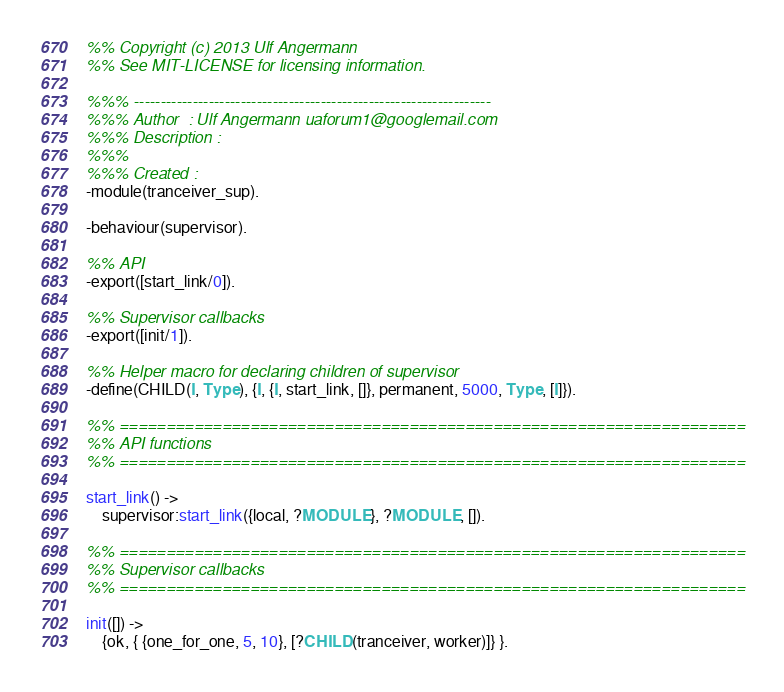<code> <loc_0><loc_0><loc_500><loc_500><_Erlang_>%% Copyright (c) 2013 Ulf Angermann
%% See MIT-LICENSE for licensing information.

%%% -------------------------------------------------------------------
%%% Author  : Ulf Angermann uaforum1@googlemail.com
%%% Description :
%%%
%%% Created : 
-module(tranceiver_sup).

-behaviour(supervisor).

%% API
-export([start_link/0]).

%% Supervisor callbacks
-export([init/1]).

%% Helper macro for declaring children of supervisor
-define(CHILD(I, Type), {I, {I, start_link, []}, permanent, 5000, Type, [I]}).

%% ===================================================================
%% API functions
%% ===================================================================

start_link() ->
    supervisor:start_link({local, ?MODULE}, ?MODULE, []).

%% ===================================================================
%% Supervisor callbacks
%% ===================================================================

init([]) ->
    {ok, { {one_for_one, 5, 10}, [?CHILD(tranceiver, worker)]} }.

</code> 